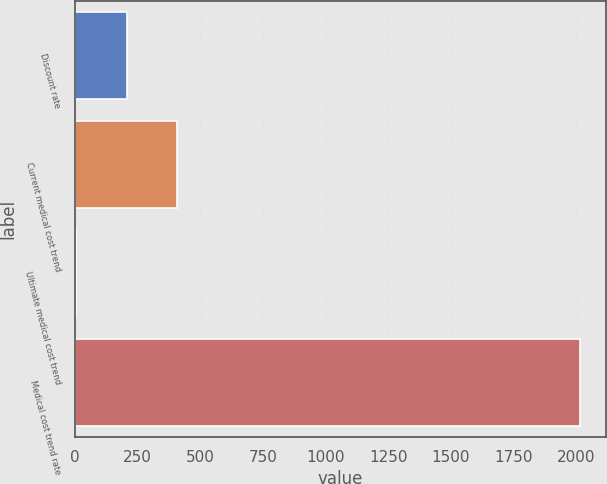Convert chart to OTSL. <chart><loc_0><loc_0><loc_500><loc_500><bar_chart><fcel>Discount rate<fcel>Current medical cost trend<fcel>Ultimate medical cost trend<fcel>Medical cost trend rate<nl><fcel>205.88<fcel>407<fcel>4.75<fcel>2016<nl></chart> 